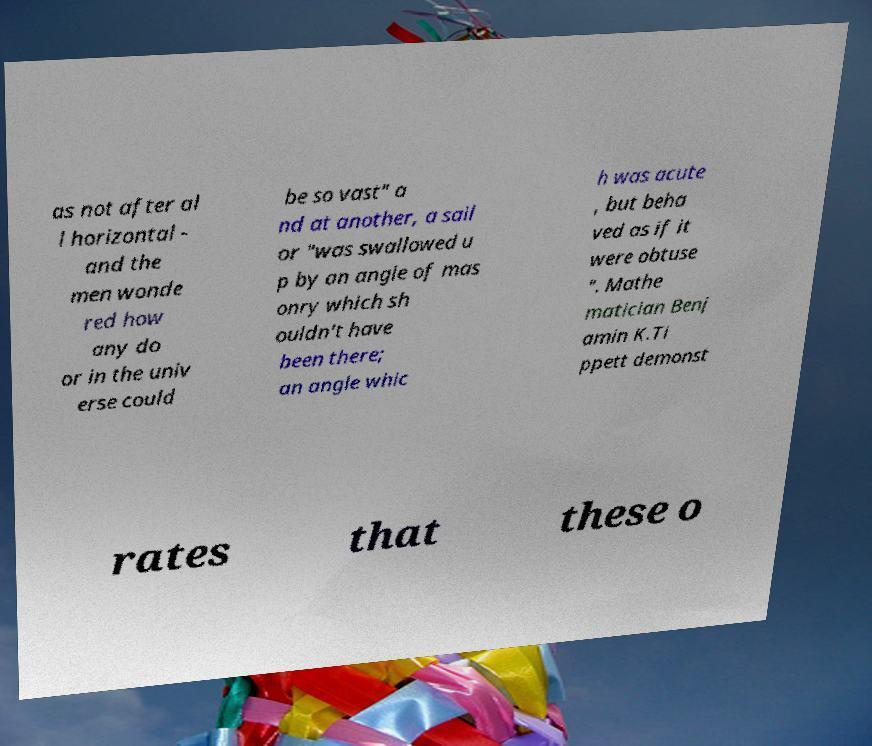Can you read and provide the text displayed in the image?This photo seems to have some interesting text. Can you extract and type it out for me? as not after al l horizontal - and the men wonde red how any do or in the univ erse could be so vast" a nd at another, a sail or "was swallowed u p by an angle of mas onry which sh ouldn't have been there; an angle whic h was acute , but beha ved as if it were obtuse ". Mathe matician Benj amin K.Ti ppett demonst rates that these o 